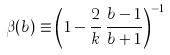Convert formula to latex. <formula><loc_0><loc_0><loc_500><loc_500>\beta ( b ) \equiv \left ( 1 - \frac { 2 } { k } \, \frac { b - 1 } { b + 1 } \right ) ^ { - 1 }</formula> 